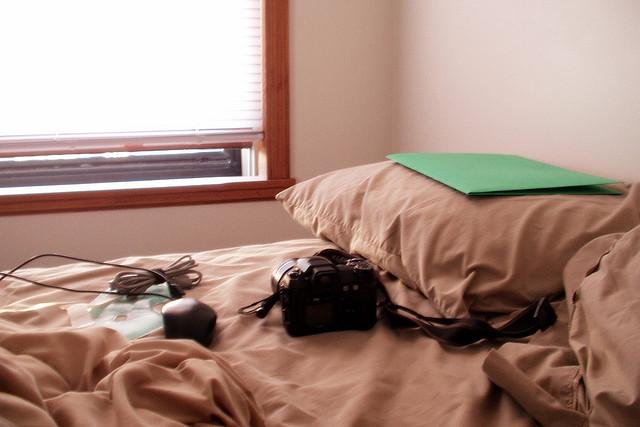Where are the shoes?
Short answer required. Floor. What is green colored on the pillow?
Keep it brief. Folder. What color is the bed?
Be succinct. Tan. Is this bed made?
Quick response, please. No. What is open?
Concise answer only. Window. 